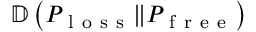Convert formula to latex. <formula><loc_0><loc_0><loc_500><loc_500>\mathbb { D } \left ( P _ { l o s s } \| P _ { f r e e } \right )</formula> 